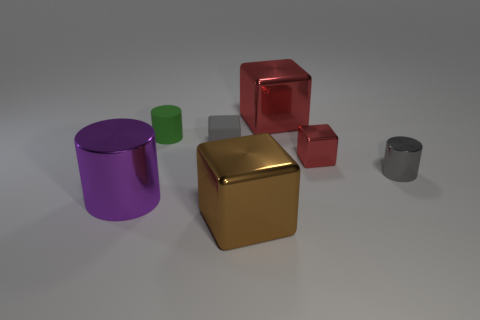There is a thing that is the same color as the rubber block; what size is it?
Offer a terse response. Small. What material is the purple object?
Offer a very short reply. Metal. Do the big cylinder and the tiny matte cube have the same color?
Ensure brevity in your answer.  No. Is the number of green matte cylinders in front of the gray metal object less than the number of big purple cylinders?
Provide a short and direct response. Yes. What is the color of the cylinder that is in front of the tiny metallic cylinder?
Offer a very short reply. Purple. The green matte thing has what shape?
Offer a very short reply. Cylinder. Is there a tiny gray thing left of the large shiny thing behind the gray thing on the left side of the large red metallic block?
Ensure brevity in your answer.  Yes. The small metal object that is to the left of the tiny cylinder on the right side of the large block that is in front of the large red cube is what color?
Provide a succinct answer. Red. What is the material of the gray thing that is the same shape as the green matte object?
Your answer should be compact. Metal. There is a red cube to the left of the red metallic cube in front of the tiny rubber block; how big is it?
Offer a terse response. Large. 